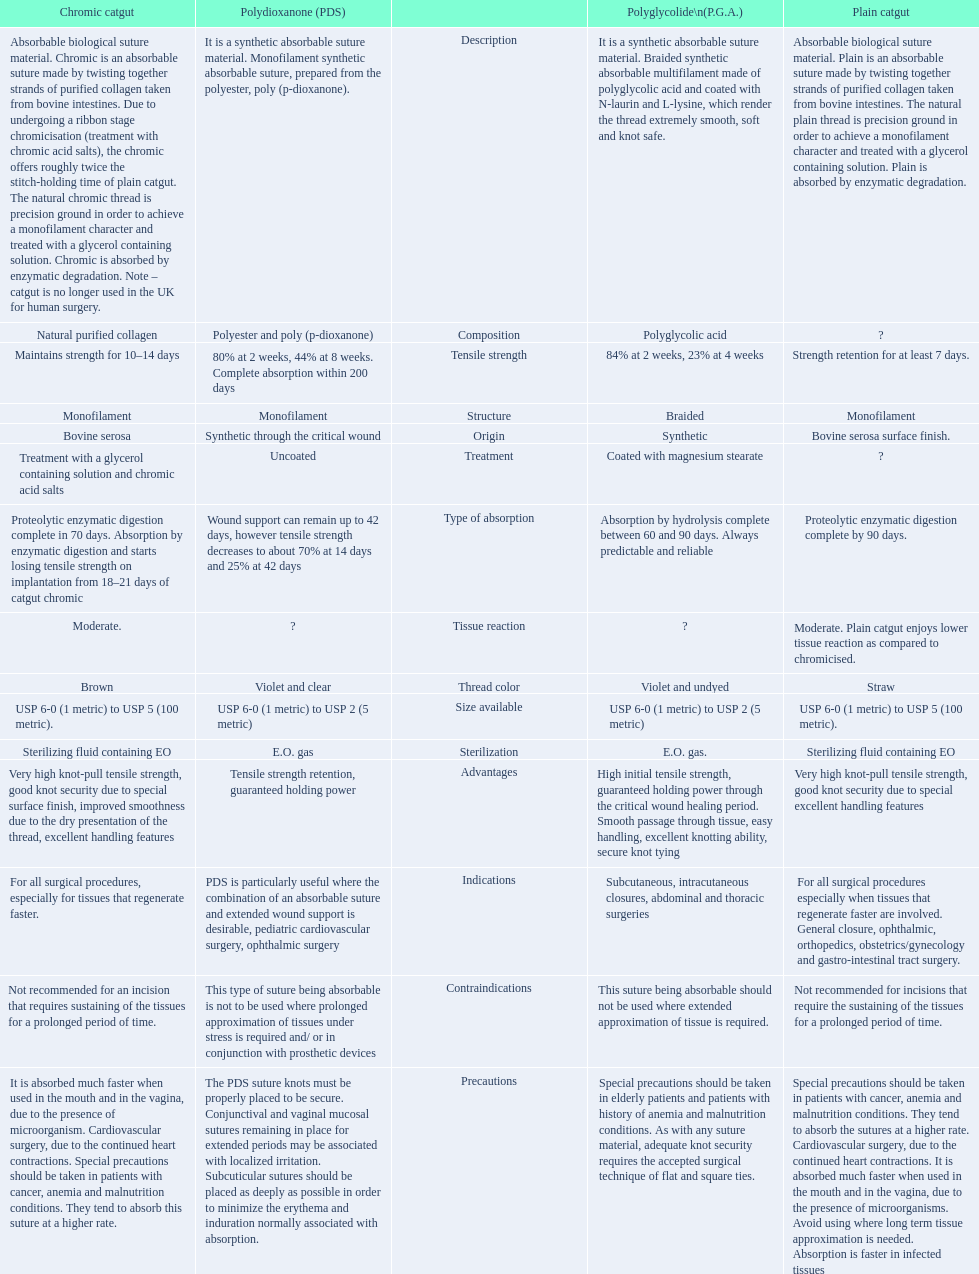Which are the different tensile strengths of the suture materials in the comparison chart? Strength retention for at least 7 days., Maintains strength for 10–14 days, 84% at 2 weeks, 23% at 4 weeks, 80% at 2 weeks, 44% at 8 weeks. Complete absorption within 200 days. Of these, which belongs to plain catgut? Strength retention for at least 7 days. 